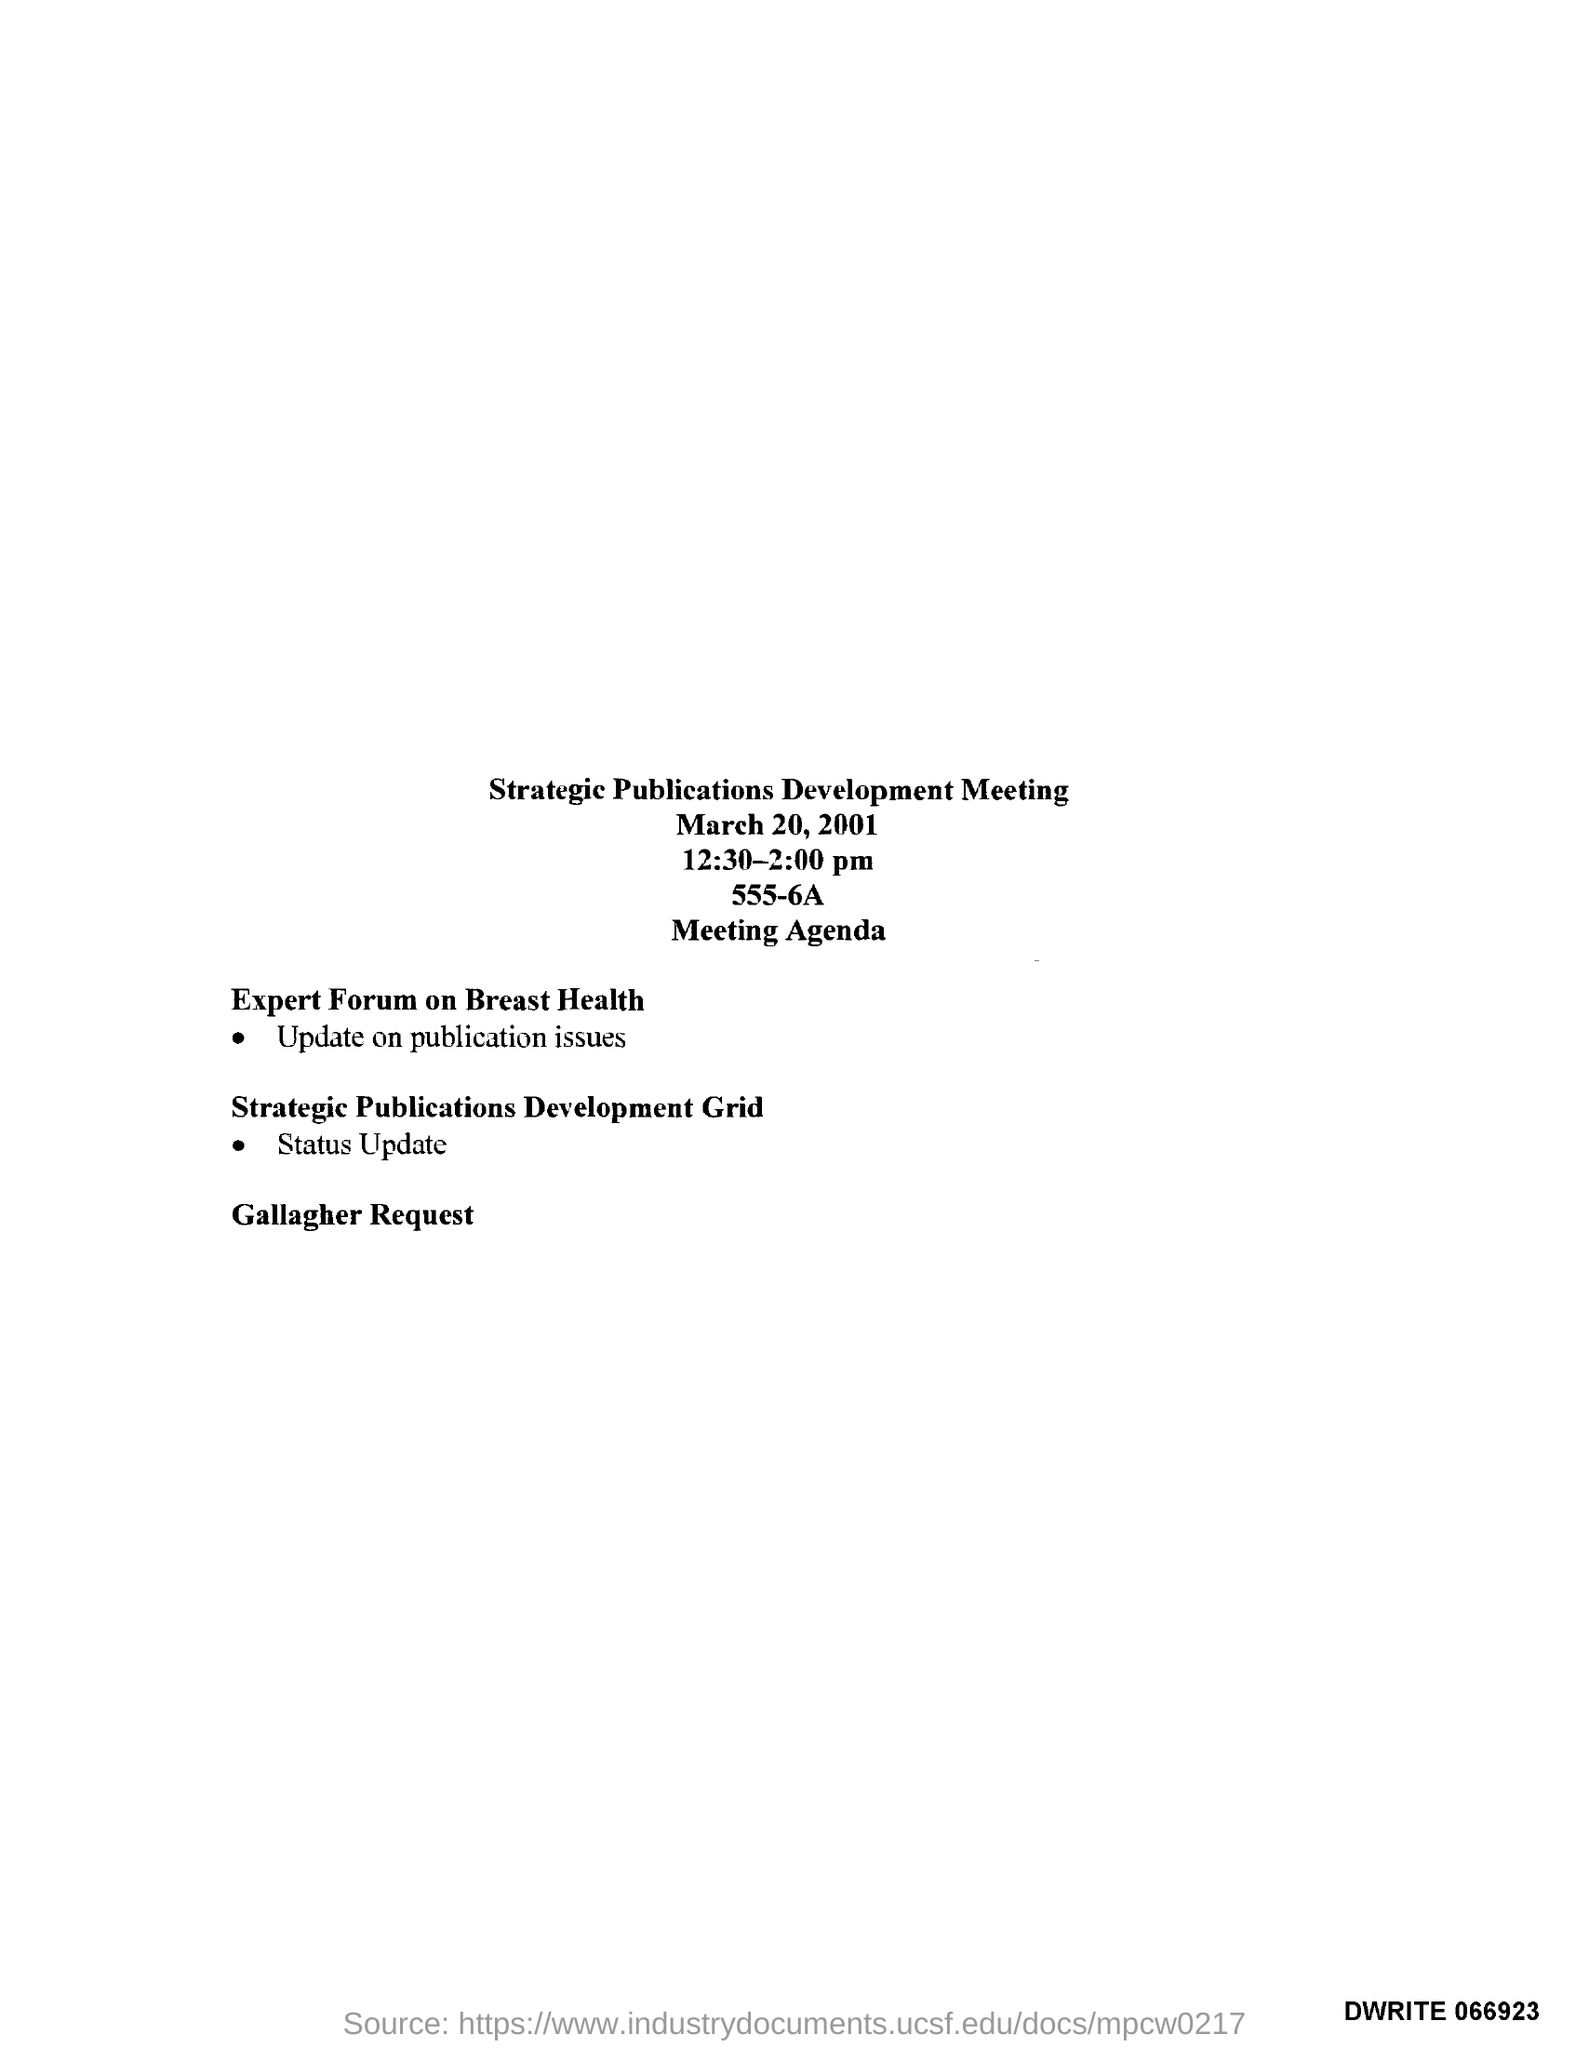What is the Title of the document ?
Offer a very short reply. Strategic Publications Development Meeting. What is the date mentioned in the top of the document ?
Make the answer very short. March 20, 2001. What is the Timing of Meeting ?
Offer a very short reply. 12:30-2:00 pm. 